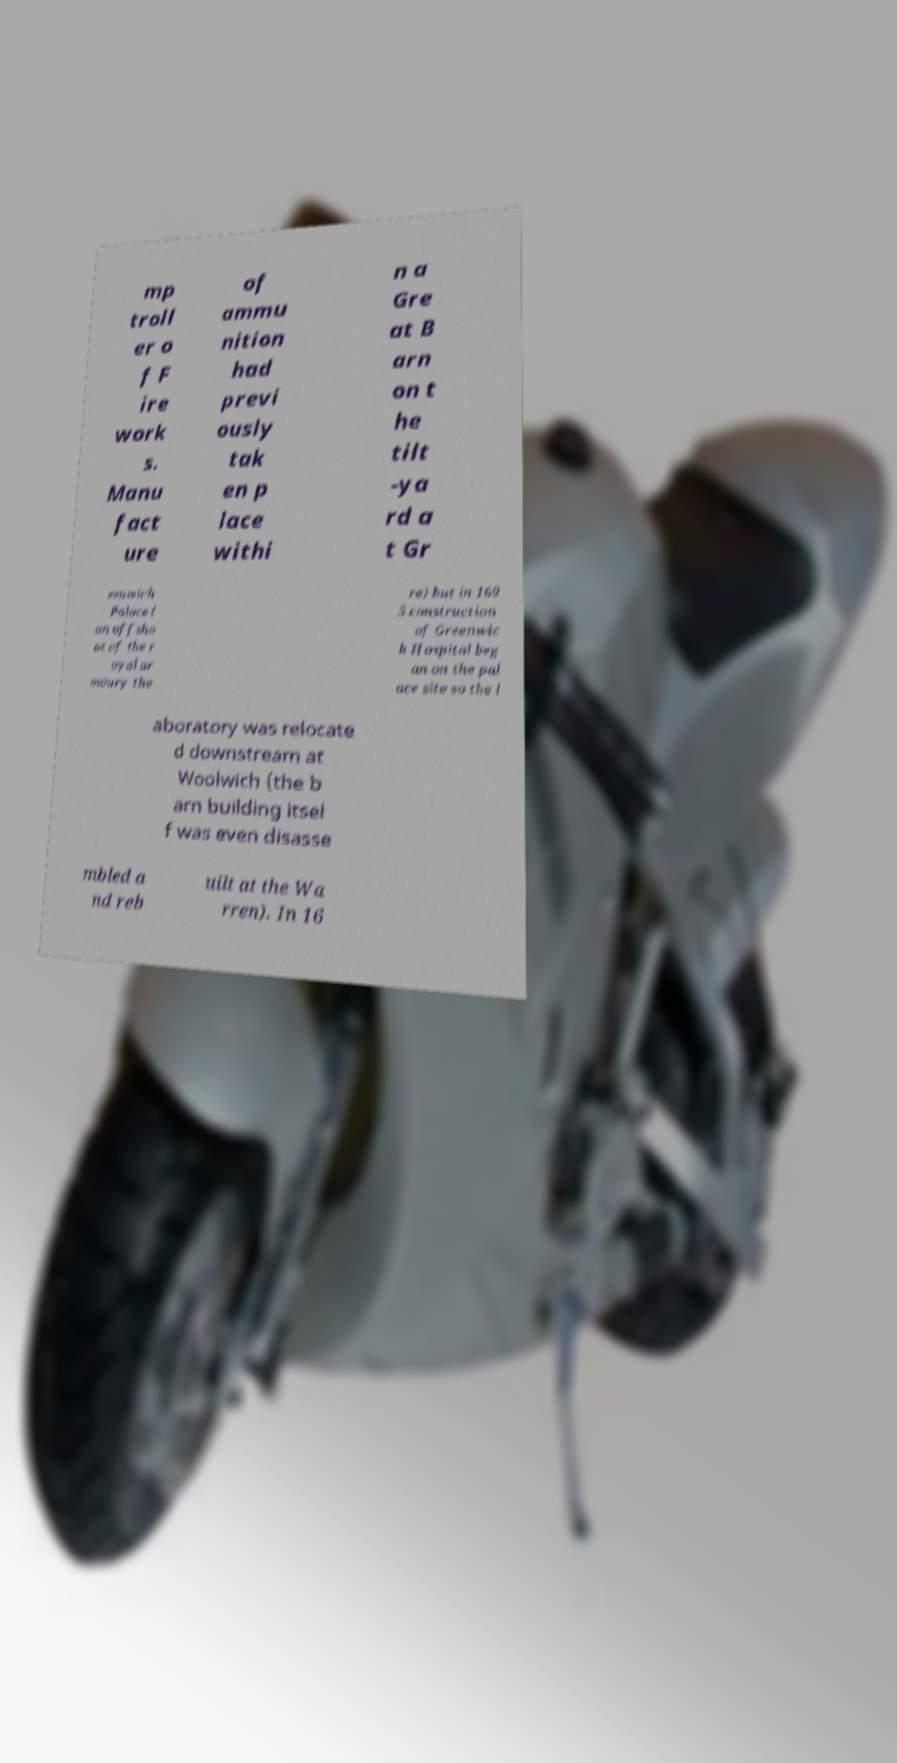Please read and relay the text visible in this image. What does it say? mp troll er o f F ire work s. Manu fact ure of ammu nition had previ ously tak en p lace withi n a Gre at B arn on t he tilt -ya rd a t Gr eenwich Palace ( an offsho ot of the r oyal ar moury the re) but in 169 5 construction of Greenwic h Hospital beg an on the pal ace site so the l aboratory was relocate d downstream at Woolwich (the b arn building itsel f was even disasse mbled a nd reb uilt at the Wa rren). In 16 